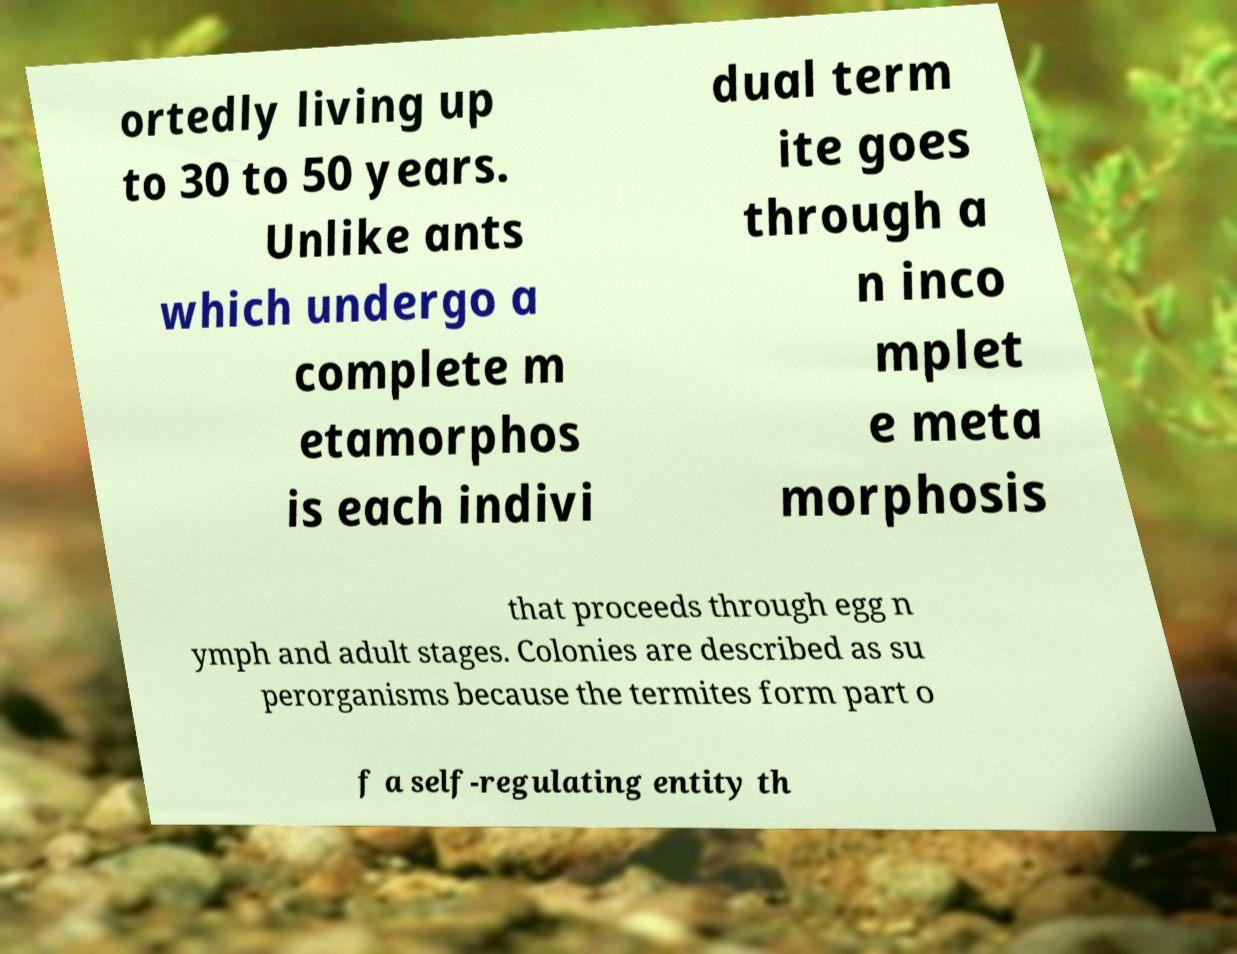There's text embedded in this image that I need extracted. Can you transcribe it verbatim? ortedly living up to 30 to 50 years. Unlike ants which undergo a complete m etamorphos is each indivi dual term ite goes through a n inco mplet e meta morphosis that proceeds through egg n ymph and adult stages. Colonies are described as su perorganisms because the termites form part o f a self-regulating entity th 